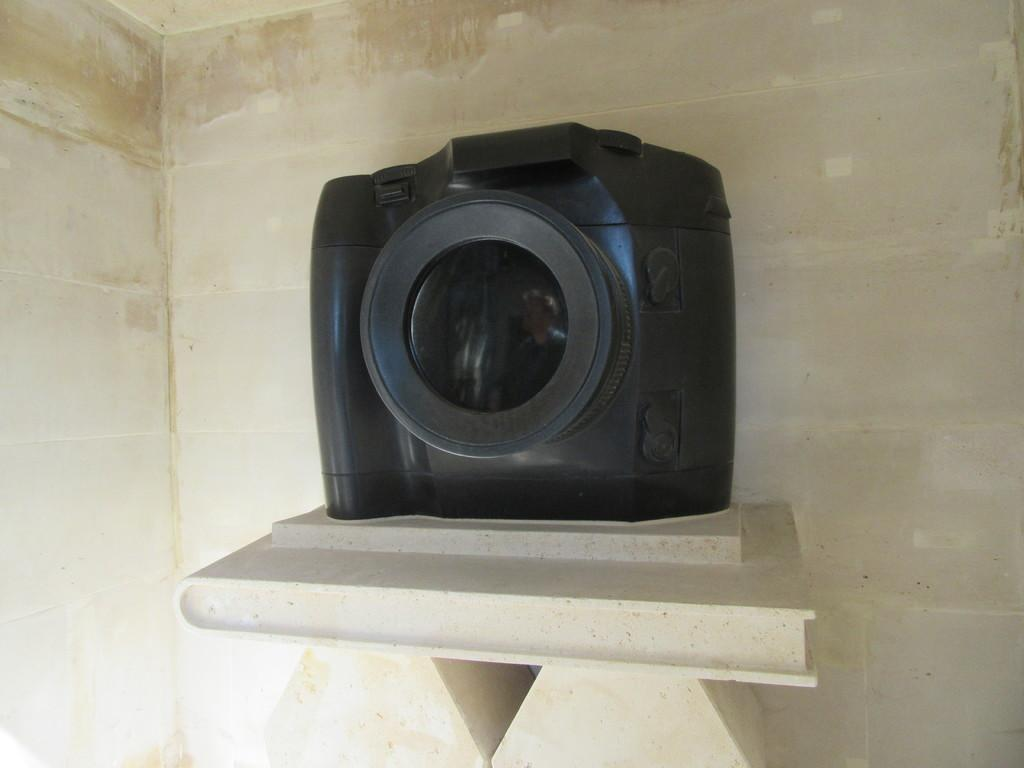What is the main subject of the image? There is a depiction of a camera in the center of the image. What can be seen in the background of the image? There is a wall in the background of the image. What type of insurance is being sold at the shop in the image? There is no shop present in the image, and therefore no insurance being sold. What is the condition of the person's neck in the image? There are no people or necks visible in the image, as it only features a depiction of a camera and a wall in the background. 